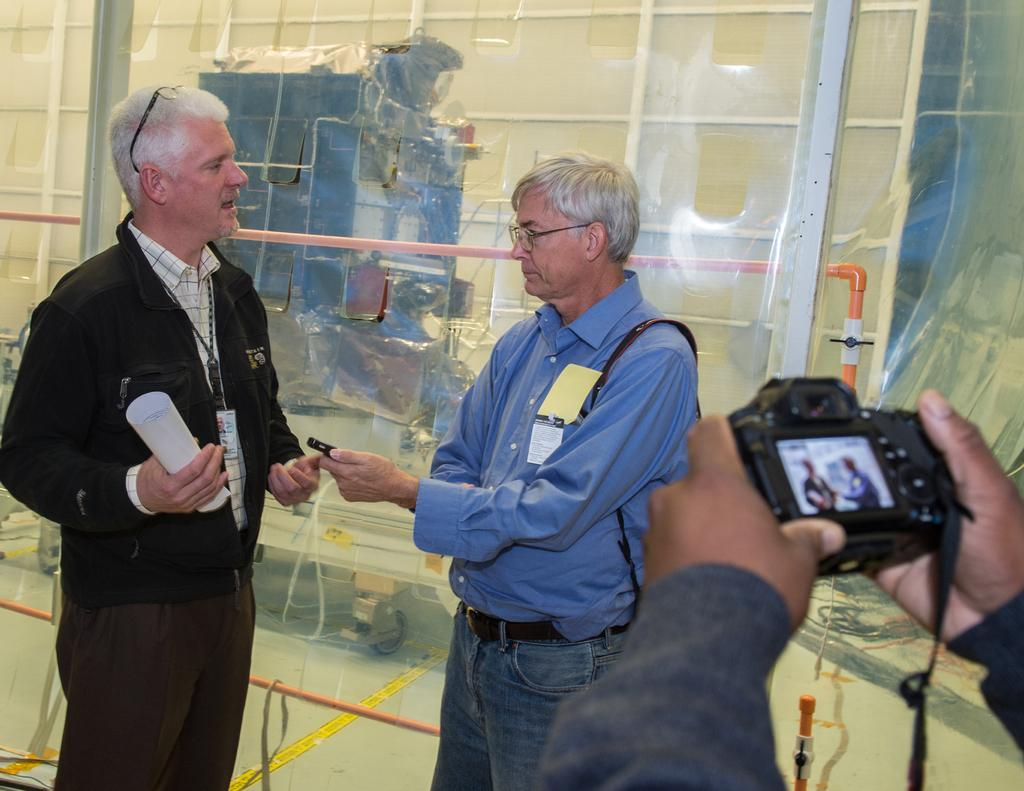How many people are in the image? There are two persons in the image. What are the two persons doing? The two persons are discussing with each other. Is there anyone else in the image besides the two persons? Yes, there is a person taking a photograph of the two persons. Where is the person taking the photograph located in the image? The person taking the photograph is at the right side of the image. What type of meal is being prepared in the cellar in the image? There is no cellar or meal preparation present in the image. Can you hear the conversation between the two persons in the image? We cannot hear the conversation between the two persons in the image, as it is a visual medium. 